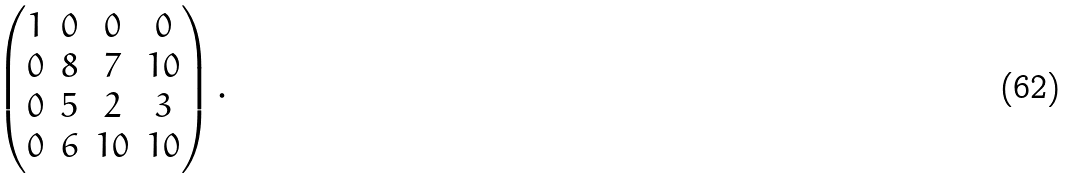Convert formula to latex. <formula><loc_0><loc_0><loc_500><loc_500>\begin{pmatrix} 1 & 0 & 0 & 0 \\ 0 & 8 & 7 & 1 0 \\ 0 & 5 & 2 & 3 \\ 0 & 6 & 1 0 & 1 0 \end{pmatrix} .</formula> 